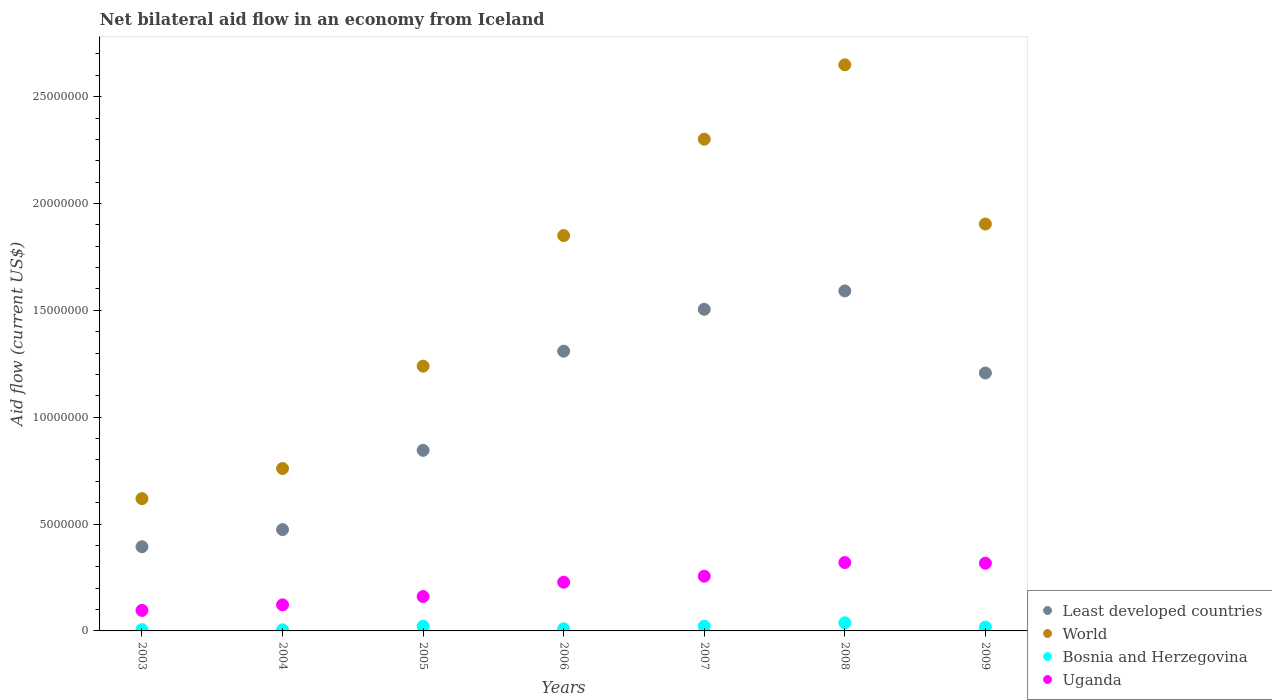How many different coloured dotlines are there?
Make the answer very short. 4. What is the net bilateral aid flow in World in 2008?
Offer a terse response. 2.65e+07. Across all years, what is the maximum net bilateral aid flow in Least developed countries?
Your answer should be very brief. 1.59e+07. Across all years, what is the minimum net bilateral aid flow in World?
Your response must be concise. 6.19e+06. What is the total net bilateral aid flow in World in the graph?
Your answer should be compact. 1.13e+08. What is the difference between the net bilateral aid flow in Uganda in 2008 and that in 2009?
Provide a succinct answer. 3.00e+04. What is the difference between the net bilateral aid flow in Least developed countries in 2006 and the net bilateral aid flow in Uganda in 2005?
Offer a terse response. 1.15e+07. What is the average net bilateral aid flow in Uganda per year?
Provide a short and direct response. 2.14e+06. In the year 2009, what is the difference between the net bilateral aid flow in Bosnia and Herzegovina and net bilateral aid flow in Least developed countries?
Your response must be concise. -1.19e+07. What is the difference between the highest and the second highest net bilateral aid flow in Least developed countries?
Ensure brevity in your answer.  8.60e+05. What is the difference between the highest and the lowest net bilateral aid flow in Least developed countries?
Provide a short and direct response. 1.20e+07. Is the sum of the net bilateral aid flow in Least developed countries in 2004 and 2007 greater than the maximum net bilateral aid flow in Uganda across all years?
Your answer should be very brief. Yes. Is it the case that in every year, the sum of the net bilateral aid flow in Uganda and net bilateral aid flow in Bosnia and Herzegovina  is greater than the sum of net bilateral aid flow in Least developed countries and net bilateral aid flow in World?
Make the answer very short. No. Is it the case that in every year, the sum of the net bilateral aid flow in Least developed countries and net bilateral aid flow in Uganda  is greater than the net bilateral aid flow in Bosnia and Herzegovina?
Make the answer very short. Yes. Does the net bilateral aid flow in Uganda monotonically increase over the years?
Make the answer very short. No. Is the net bilateral aid flow in Bosnia and Herzegovina strictly greater than the net bilateral aid flow in Uganda over the years?
Your answer should be very brief. No. How many dotlines are there?
Provide a short and direct response. 4. What is the difference between two consecutive major ticks on the Y-axis?
Provide a short and direct response. 5.00e+06. Does the graph contain grids?
Ensure brevity in your answer.  No. Where does the legend appear in the graph?
Make the answer very short. Bottom right. How many legend labels are there?
Give a very brief answer. 4. How are the legend labels stacked?
Offer a very short reply. Vertical. What is the title of the graph?
Keep it short and to the point. Net bilateral aid flow in an economy from Iceland. Does "Luxembourg" appear as one of the legend labels in the graph?
Your answer should be compact. No. What is the label or title of the X-axis?
Provide a succinct answer. Years. What is the label or title of the Y-axis?
Your answer should be compact. Aid flow (current US$). What is the Aid flow (current US$) of Least developed countries in 2003?
Offer a terse response. 3.94e+06. What is the Aid flow (current US$) of World in 2003?
Give a very brief answer. 6.19e+06. What is the Aid flow (current US$) of Bosnia and Herzegovina in 2003?
Your answer should be very brief. 6.00e+04. What is the Aid flow (current US$) in Uganda in 2003?
Offer a terse response. 9.60e+05. What is the Aid flow (current US$) of Least developed countries in 2004?
Your answer should be compact. 4.74e+06. What is the Aid flow (current US$) in World in 2004?
Give a very brief answer. 7.60e+06. What is the Aid flow (current US$) of Bosnia and Herzegovina in 2004?
Offer a terse response. 5.00e+04. What is the Aid flow (current US$) of Uganda in 2004?
Your answer should be very brief. 1.22e+06. What is the Aid flow (current US$) of Least developed countries in 2005?
Your answer should be very brief. 8.45e+06. What is the Aid flow (current US$) in World in 2005?
Your answer should be compact. 1.24e+07. What is the Aid flow (current US$) of Bosnia and Herzegovina in 2005?
Keep it short and to the point. 2.20e+05. What is the Aid flow (current US$) of Uganda in 2005?
Your response must be concise. 1.61e+06. What is the Aid flow (current US$) of Least developed countries in 2006?
Provide a short and direct response. 1.31e+07. What is the Aid flow (current US$) of World in 2006?
Offer a terse response. 1.85e+07. What is the Aid flow (current US$) of Uganda in 2006?
Offer a terse response. 2.28e+06. What is the Aid flow (current US$) of Least developed countries in 2007?
Give a very brief answer. 1.50e+07. What is the Aid flow (current US$) of World in 2007?
Make the answer very short. 2.30e+07. What is the Aid flow (current US$) in Bosnia and Herzegovina in 2007?
Your answer should be compact. 2.20e+05. What is the Aid flow (current US$) of Uganda in 2007?
Your response must be concise. 2.56e+06. What is the Aid flow (current US$) of Least developed countries in 2008?
Your answer should be compact. 1.59e+07. What is the Aid flow (current US$) in World in 2008?
Your response must be concise. 2.65e+07. What is the Aid flow (current US$) of Uganda in 2008?
Keep it short and to the point. 3.20e+06. What is the Aid flow (current US$) in Least developed countries in 2009?
Provide a short and direct response. 1.21e+07. What is the Aid flow (current US$) of World in 2009?
Your response must be concise. 1.90e+07. What is the Aid flow (current US$) in Bosnia and Herzegovina in 2009?
Offer a terse response. 1.80e+05. What is the Aid flow (current US$) of Uganda in 2009?
Make the answer very short. 3.17e+06. Across all years, what is the maximum Aid flow (current US$) in Least developed countries?
Your answer should be very brief. 1.59e+07. Across all years, what is the maximum Aid flow (current US$) in World?
Make the answer very short. 2.65e+07. Across all years, what is the maximum Aid flow (current US$) in Uganda?
Offer a very short reply. 3.20e+06. Across all years, what is the minimum Aid flow (current US$) in Least developed countries?
Your answer should be compact. 3.94e+06. Across all years, what is the minimum Aid flow (current US$) in World?
Your answer should be very brief. 6.19e+06. Across all years, what is the minimum Aid flow (current US$) of Uganda?
Offer a very short reply. 9.60e+05. What is the total Aid flow (current US$) of Least developed countries in the graph?
Your response must be concise. 7.32e+07. What is the total Aid flow (current US$) of World in the graph?
Provide a succinct answer. 1.13e+08. What is the total Aid flow (current US$) of Bosnia and Herzegovina in the graph?
Provide a succinct answer. 1.21e+06. What is the total Aid flow (current US$) of Uganda in the graph?
Your answer should be very brief. 1.50e+07. What is the difference between the Aid flow (current US$) of Least developed countries in 2003 and that in 2004?
Offer a very short reply. -8.00e+05. What is the difference between the Aid flow (current US$) of World in 2003 and that in 2004?
Offer a very short reply. -1.41e+06. What is the difference between the Aid flow (current US$) in Bosnia and Herzegovina in 2003 and that in 2004?
Your answer should be very brief. 10000. What is the difference between the Aid flow (current US$) of Uganda in 2003 and that in 2004?
Your answer should be very brief. -2.60e+05. What is the difference between the Aid flow (current US$) in Least developed countries in 2003 and that in 2005?
Provide a succinct answer. -4.51e+06. What is the difference between the Aid flow (current US$) in World in 2003 and that in 2005?
Make the answer very short. -6.20e+06. What is the difference between the Aid flow (current US$) of Uganda in 2003 and that in 2005?
Give a very brief answer. -6.50e+05. What is the difference between the Aid flow (current US$) of Least developed countries in 2003 and that in 2006?
Provide a succinct answer. -9.15e+06. What is the difference between the Aid flow (current US$) of World in 2003 and that in 2006?
Provide a succinct answer. -1.23e+07. What is the difference between the Aid flow (current US$) of Uganda in 2003 and that in 2006?
Give a very brief answer. -1.32e+06. What is the difference between the Aid flow (current US$) in Least developed countries in 2003 and that in 2007?
Provide a succinct answer. -1.11e+07. What is the difference between the Aid flow (current US$) in World in 2003 and that in 2007?
Provide a succinct answer. -1.68e+07. What is the difference between the Aid flow (current US$) in Bosnia and Herzegovina in 2003 and that in 2007?
Your response must be concise. -1.60e+05. What is the difference between the Aid flow (current US$) in Uganda in 2003 and that in 2007?
Your response must be concise. -1.60e+06. What is the difference between the Aid flow (current US$) in Least developed countries in 2003 and that in 2008?
Your answer should be compact. -1.20e+07. What is the difference between the Aid flow (current US$) in World in 2003 and that in 2008?
Keep it short and to the point. -2.03e+07. What is the difference between the Aid flow (current US$) in Bosnia and Herzegovina in 2003 and that in 2008?
Ensure brevity in your answer.  -3.20e+05. What is the difference between the Aid flow (current US$) of Uganda in 2003 and that in 2008?
Provide a short and direct response. -2.24e+06. What is the difference between the Aid flow (current US$) of Least developed countries in 2003 and that in 2009?
Make the answer very short. -8.13e+06. What is the difference between the Aid flow (current US$) in World in 2003 and that in 2009?
Provide a succinct answer. -1.28e+07. What is the difference between the Aid flow (current US$) in Uganda in 2003 and that in 2009?
Your answer should be very brief. -2.21e+06. What is the difference between the Aid flow (current US$) in Least developed countries in 2004 and that in 2005?
Give a very brief answer. -3.71e+06. What is the difference between the Aid flow (current US$) of World in 2004 and that in 2005?
Your response must be concise. -4.79e+06. What is the difference between the Aid flow (current US$) in Uganda in 2004 and that in 2005?
Provide a short and direct response. -3.90e+05. What is the difference between the Aid flow (current US$) of Least developed countries in 2004 and that in 2006?
Keep it short and to the point. -8.35e+06. What is the difference between the Aid flow (current US$) of World in 2004 and that in 2006?
Provide a succinct answer. -1.09e+07. What is the difference between the Aid flow (current US$) of Uganda in 2004 and that in 2006?
Your answer should be compact. -1.06e+06. What is the difference between the Aid flow (current US$) in Least developed countries in 2004 and that in 2007?
Keep it short and to the point. -1.03e+07. What is the difference between the Aid flow (current US$) in World in 2004 and that in 2007?
Ensure brevity in your answer.  -1.54e+07. What is the difference between the Aid flow (current US$) of Uganda in 2004 and that in 2007?
Your answer should be very brief. -1.34e+06. What is the difference between the Aid flow (current US$) in Least developed countries in 2004 and that in 2008?
Ensure brevity in your answer.  -1.12e+07. What is the difference between the Aid flow (current US$) in World in 2004 and that in 2008?
Your answer should be very brief. -1.89e+07. What is the difference between the Aid flow (current US$) in Bosnia and Herzegovina in 2004 and that in 2008?
Your answer should be compact. -3.30e+05. What is the difference between the Aid flow (current US$) of Uganda in 2004 and that in 2008?
Ensure brevity in your answer.  -1.98e+06. What is the difference between the Aid flow (current US$) in Least developed countries in 2004 and that in 2009?
Your response must be concise. -7.33e+06. What is the difference between the Aid flow (current US$) in World in 2004 and that in 2009?
Provide a short and direct response. -1.14e+07. What is the difference between the Aid flow (current US$) of Uganda in 2004 and that in 2009?
Keep it short and to the point. -1.95e+06. What is the difference between the Aid flow (current US$) in Least developed countries in 2005 and that in 2006?
Make the answer very short. -4.64e+06. What is the difference between the Aid flow (current US$) of World in 2005 and that in 2006?
Your answer should be compact. -6.11e+06. What is the difference between the Aid flow (current US$) of Bosnia and Herzegovina in 2005 and that in 2006?
Your response must be concise. 1.20e+05. What is the difference between the Aid flow (current US$) in Uganda in 2005 and that in 2006?
Provide a short and direct response. -6.70e+05. What is the difference between the Aid flow (current US$) of Least developed countries in 2005 and that in 2007?
Make the answer very short. -6.60e+06. What is the difference between the Aid flow (current US$) in World in 2005 and that in 2007?
Offer a very short reply. -1.06e+07. What is the difference between the Aid flow (current US$) in Bosnia and Herzegovina in 2005 and that in 2007?
Provide a short and direct response. 0. What is the difference between the Aid flow (current US$) of Uganda in 2005 and that in 2007?
Offer a terse response. -9.50e+05. What is the difference between the Aid flow (current US$) in Least developed countries in 2005 and that in 2008?
Provide a short and direct response. -7.46e+06. What is the difference between the Aid flow (current US$) of World in 2005 and that in 2008?
Your answer should be compact. -1.41e+07. What is the difference between the Aid flow (current US$) of Uganda in 2005 and that in 2008?
Your response must be concise. -1.59e+06. What is the difference between the Aid flow (current US$) of Least developed countries in 2005 and that in 2009?
Your answer should be very brief. -3.62e+06. What is the difference between the Aid flow (current US$) of World in 2005 and that in 2009?
Provide a succinct answer. -6.65e+06. What is the difference between the Aid flow (current US$) of Bosnia and Herzegovina in 2005 and that in 2009?
Your response must be concise. 4.00e+04. What is the difference between the Aid flow (current US$) in Uganda in 2005 and that in 2009?
Ensure brevity in your answer.  -1.56e+06. What is the difference between the Aid flow (current US$) of Least developed countries in 2006 and that in 2007?
Offer a very short reply. -1.96e+06. What is the difference between the Aid flow (current US$) of World in 2006 and that in 2007?
Your answer should be compact. -4.51e+06. What is the difference between the Aid flow (current US$) of Bosnia and Herzegovina in 2006 and that in 2007?
Your response must be concise. -1.20e+05. What is the difference between the Aid flow (current US$) in Uganda in 2006 and that in 2007?
Provide a short and direct response. -2.80e+05. What is the difference between the Aid flow (current US$) in Least developed countries in 2006 and that in 2008?
Offer a terse response. -2.82e+06. What is the difference between the Aid flow (current US$) of World in 2006 and that in 2008?
Offer a terse response. -7.99e+06. What is the difference between the Aid flow (current US$) of Bosnia and Herzegovina in 2006 and that in 2008?
Your answer should be compact. -2.80e+05. What is the difference between the Aid flow (current US$) of Uganda in 2006 and that in 2008?
Your answer should be compact. -9.20e+05. What is the difference between the Aid flow (current US$) of Least developed countries in 2006 and that in 2009?
Your answer should be compact. 1.02e+06. What is the difference between the Aid flow (current US$) of World in 2006 and that in 2009?
Provide a short and direct response. -5.40e+05. What is the difference between the Aid flow (current US$) in Bosnia and Herzegovina in 2006 and that in 2009?
Your answer should be compact. -8.00e+04. What is the difference between the Aid flow (current US$) of Uganda in 2006 and that in 2009?
Ensure brevity in your answer.  -8.90e+05. What is the difference between the Aid flow (current US$) of Least developed countries in 2007 and that in 2008?
Offer a very short reply. -8.60e+05. What is the difference between the Aid flow (current US$) in World in 2007 and that in 2008?
Offer a terse response. -3.48e+06. What is the difference between the Aid flow (current US$) in Bosnia and Herzegovina in 2007 and that in 2008?
Your answer should be compact. -1.60e+05. What is the difference between the Aid flow (current US$) in Uganda in 2007 and that in 2008?
Your answer should be very brief. -6.40e+05. What is the difference between the Aid flow (current US$) in Least developed countries in 2007 and that in 2009?
Offer a very short reply. 2.98e+06. What is the difference between the Aid flow (current US$) of World in 2007 and that in 2009?
Offer a terse response. 3.97e+06. What is the difference between the Aid flow (current US$) of Bosnia and Herzegovina in 2007 and that in 2009?
Ensure brevity in your answer.  4.00e+04. What is the difference between the Aid flow (current US$) of Uganda in 2007 and that in 2009?
Your response must be concise. -6.10e+05. What is the difference between the Aid flow (current US$) in Least developed countries in 2008 and that in 2009?
Provide a succinct answer. 3.84e+06. What is the difference between the Aid flow (current US$) in World in 2008 and that in 2009?
Ensure brevity in your answer.  7.45e+06. What is the difference between the Aid flow (current US$) in Bosnia and Herzegovina in 2008 and that in 2009?
Provide a short and direct response. 2.00e+05. What is the difference between the Aid flow (current US$) of Uganda in 2008 and that in 2009?
Make the answer very short. 3.00e+04. What is the difference between the Aid flow (current US$) of Least developed countries in 2003 and the Aid flow (current US$) of World in 2004?
Ensure brevity in your answer.  -3.66e+06. What is the difference between the Aid flow (current US$) in Least developed countries in 2003 and the Aid flow (current US$) in Bosnia and Herzegovina in 2004?
Your answer should be compact. 3.89e+06. What is the difference between the Aid flow (current US$) in Least developed countries in 2003 and the Aid flow (current US$) in Uganda in 2004?
Ensure brevity in your answer.  2.72e+06. What is the difference between the Aid flow (current US$) in World in 2003 and the Aid flow (current US$) in Bosnia and Herzegovina in 2004?
Make the answer very short. 6.14e+06. What is the difference between the Aid flow (current US$) in World in 2003 and the Aid flow (current US$) in Uganda in 2004?
Give a very brief answer. 4.97e+06. What is the difference between the Aid flow (current US$) in Bosnia and Herzegovina in 2003 and the Aid flow (current US$) in Uganda in 2004?
Provide a succinct answer. -1.16e+06. What is the difference between the Aid flow (current US$) in Least developed countries in 2003 and the Aid flow (current US$) in World in 2005?
Your response must be concise. -8.45e+06. What is the difference between the Aid flow (current US$) in Least developed countries in 2003 and the Aid flow (current US$) in Bosnia and Herzegovina in 2005?
Provide a short and direct response. 3.72e+06. What is the difference between the Aid flow (current US$) of Least developed countries in 2003 and the Aid flow (current US$) of Uganda in 2005?
Your response must be concise. 2.33e+06. What is the difference between the Aid flow (current US$) of World in 2003 and the Aid flow (current US$) of Bosnia and Herzegovina in 2005?
Your answer should be compact. 5.97e+06. What is the difference between the Aid flow (current US$) in World in 2003 and the Aid flow (current US$) in Uganda in 2005?
Your response must be concise. 4.58e+06. What is the difference between the Aid flow (current US$) in Bosnia and Herzegovina in 2003 and the Aid flow (current US$) in Uganda in 2005?
Offer a terse response. -1.55e+06. What is the difference between the Aid flow (current US$) of Least developed countries in 2003 and the Aid flow (current US$) of World in 2006?
Ensure brevity in your answer.  -1.46e+07. What is the difference between the Aid flow (current US$) of Least developed countries in 2003 and the Aid flow (current US$) of Bosnia and Herzegovina in 2006?
Offer a very short reply. 3.84e+06. What is the difference between the Aid flow (current US$) of Least developed countries in 2003 and the Aid flow (current US$) of Uganda in 2006?
Make the answer very short. 1.66e+06. What is the difference between the Aid flow (current US$) of World in 2003 and the Aid flow (current US$) of Bosnia and Herzegovina in 2006?
Your answer should be very brief. 6.09e+06. What is the difference between the Aid flow (current US$) in World in 2003 and the Aid flow (current US$) in Uganda in 2006?
Your response must be concise. 3.91e+06. What is the difference between the Aid flow (current US$) of Bosnia and Herzegovina in 2003 and the Aid flow (current US$) of Uganda in 2006?
Give a very brief answer. -2.22e+06. What is the difference between the Aid flow (current US$) in Least developed countries in 2003 and the Aid flow (current US$) in World in 2007?
Provide a short and direct response. -1.91e+07. What is the difference between the Aid flow (current US$) in Least developed countries in 2003 and the Aid flow (current US$) in Bosnia and Herzegovina in 2007?
Your answer should be very brief. 3.72e+06. What is the difference between the Aid flow (current US$) in Least developed countries in 2003 and the Aid flow (current US$) in Uganda in 2007?
Provide a short and direct response. 1.38e+06. What is the difference between the Aid flow (current US$) of World in 2003 and the Aid flow (current US$) of Bosnia and Herzegovina in 2007?
Offer a very short reply. 5.97e+06. What is the difference between the Aid flow (current US$) in World in 2003 and the Aid flow (current US$) in Uganda in 2007?
Keep it short and to the point. 3.63e+06. What is the difference between the Aid flow (current US$) of Bosnia and Herzegovina in 2003 and the Aid flow (current US$) of Uganda in 2007?
Your response must be concise. -2.50e+06. What is the difference between the Aid flow (current US$) in Least developed countries in 2003 and the Aid flow (current US$) in World in 2008?
Offer a terse response. -2.26e+07. What is the difference between the Aid flow (current US$) of Least developed countries in 2003 and the Aid flow (current US$) of Bosnia and Herzegovina in 2008?
Keep it short and to the point. 3.56e+06. What is the difference between the Aid flow (current US$) in Least developed countries in 2003 and the Aid flow (current US$) in Uganda in 2008?
Ensure brevity in your answer.  7.40e+05. What is the difference between the Aid flow (current US$) in World in 2003 and the Aid flow (current US$) in Bosnia and Herzegovina in 2008?
Your response must be concise. 5.81e+06. What is the difference between the Aid flow (current US$) in World in 2003 and the Aid flow (current US$) in Uganda in 2008?
Make the answer very short. 2.99e+06. What is the difference between the Aid flow (current US$) of Bosnia and Herzegovina in 2003 and the Aid flow (current US$) of Uganda in 2008?
Keep it short and to the point. -3.14e+06. What is the difference between the Aid flow (current US$) of Least developed countries in 2003 and the Aid flow (current US$) of World in 2009?
Keep it short and to the point. -1.51e+07. What is the difference between the Aid flow (current US$) of Least developed countries in 2003 and the Aid flow (current US$) of Bosnia and Herzegovina in 2009?
Make the answer very short. 3.76e+06. What is the difference between the Aid flow (current US$) of Least developed countries in 2003 and the Aid flow (current US$) of Uganda in 2009?
Your answer should be very brief. 7.70e+05. What is the difference between the Aid flow (current US$) of World in 2003 and the Aid flow (current US$) of Bosnia and Herzegovina in 2009?
Provide a succinct answer. 6.01e+06. What is the difference between the Aid flow (current US$) in World in 2003 and the Aid flow (current US$) in Uganda in 2009?
Provide a short and direct response. 3.02e+06. What is the difference between the Aid flow (current US$) in Bosnia and Herzegovina in 2003 and the Aid flow (current US$) in Uganda in 2009?
Offer a very short reply. -3.11e+06. What is the difference between the Aid flow (current US$) in Least developed countries in 2004 and the Aid flow (current US$) in World in 2005?
Your answer should be compact. -7.65e+06. What is the difference between the Aid flow (current US$) in Least developed countries in 2004 and the Aid flow (current US$) in Bosnia and Herzegovina in 2005?
Your answer should be very brief. 4.52e+06. What is the difference between the Aid flow (current US$) of Least developed countries in 2004 and the Aid flow (current US$) of Uganda in 2005?
Offer a terse response. 3.13e+06. What is the difference between the Aid flow (current US$) of World in 2004 and the Aid flow (current US$) of Bosnia and Herzegovina in 2005?
Ensure brevity in your answer.  7.38e+06. What is the difference between the Aid flow (current US$) of World in 2004 and the Aid flow (current US$) of Uganda in 2005?
Keep it short and to the point. 5.99e+06. What is the difference between the Aid flow (current US$) in Bosnia and Herzegovina in 2004 and the Aid flow (current US$) in Uganda in 2005?
Ensure brevity in your answer.  -1.56e+06. What is the difference between the Aid flow (current US$) of Least developed countries in 2004 and the Aid flow (current US$) of World in 2006?
Provide a short and direct response. -1.38e+07. What is the difference between the Aid flow (current US$) of Least developed countries in 2004 and the Aid flow (current US$) of Bosnia and Herzegovina in 2006?
Your response must be concise. 4.64e+06. What is the difference between the Aid flow (current US$) in Least developed countries in 2004 and the Aid flow (current US$) in Uganda in 2006?
Your response must be concise. 2.46e+06. What is the difference between the Aid flow (current US$) of World in 2004 and the Aid flow (current US$) of Bosnia and Herzegovina in 2006?
Provide a short and direct response. 7.50e+06. What is the difference between the Aid flow (current US$) in World in 2004 and the Aid flow (current US$) in Uganda in 2006?
Give a very brief answer. 5.32e+06. What is the difference between the Aid flow (current US$) of Bosnia and Herzegovina in 2004 and the Aid flow (current US$) of Uganda in 2006?
Offer a terse response. -2.23e+06. What is the difference between the Aid flow (current US$) of Least developed countries in 2004 and the Aid flow (current US$) of World in 2007?
Give a very brief answer. -1.83e+07. What is the difference between the Aid flow (current US$) of Least developed countries in 2004 and the Aid flow (current US$) of Bosnia and Herzegovina in 2007?
Make the answer very short. 4.52e+06. What is the difference between the Aid flow (current US$) in Least developed countries in 2004 and the Aid flow (current US$) in Uganda in 2007?
Provide a short and direct response. 2.18e+06. What is the difference between the Aid flow (current US$) of World in 2004 and the Aid flow (current US$) of Bosnia and Herzegovina in 2007?
Offer a terse response. 7.38e+06. What is the difference between the Aid flow (current US$) in World in 2004 and the Aid flow (current US$) in Uganda in 2007?
Your answer should be compact. 5.04e+06. What is the difference between the Aid flow (current US$) of Bosnia and Herzegovina in 2004 and the Aid flow (current US$) of Uganda in 2007?
Keep it short and to the point. -2.51e+06. What is the difference between the Aid flow (current US$) in Least developed countries in 2004 and the Aid flow (current US$) in World in 2008?
Offer a very short reply. -2.18e+07. What is the difference between the Aid flow (current US$) of Least developed countries in 2004 and the Aid flow (current US$) of Bosnia and Herzegovina in 2008?
Your answer should be very brief. 4.36e+06. What is the difference between the Aid flow (current US$) of Least developed countries in 2004 and the Aid flow (current US$) of Uganda in 2008?
Offer a very short reply. 1.54e+06. What is the difference between the Aid flow (current US$) of World in 2004 and the Aid flow (current US$) of Bosnia and Herzegovina in 2008?
Your response must be concise. 7.22e+06. What is the difference between the Aid flow (current US$) in World in 2004 and the Aid flow (current US$) in Uganda in 2008?
Your response must be concise. 4.40e+06. What is the difference between the Aid flow (current US$) of Bosnia and Herzegovina in 2004 and the Aid flow (current US$) of Uganda in 2008?
Give a very brief answer. -3.15e+06. What is the difference between the Aid flow (current US$) in Least developed countries in 2004 and the Aid flow (current US$) in World in 2009?
Give a very brief answer. -1.43e+07. What is the difference between the Aid flow (current US$) in Least developed countries in 2004 and the Aid flow (current US$) in Bosnia and Herzegovina in 2009?
Offer a very short reply. 4.56e+06. What is the difference between the Aid flow (current US$) in Least developed countries in 2004 and the Aid flow (current US$) in Uganda in 2009?
Make the answer very short. 1.57e+06. What is the difference between the Aid flow (current US$) in World in 2004 and the Aid flow (current US$) in Bosnia and Herzegovina in 2009?
Provide a short and direct response. 7.42e+06. What is the difference between the Aid flow (current US$) of World in 2004 and the Aid flow (current US$) of Uganda in 2009?
Make the answer very short. 4.43e+06. What is the difference between the Aid flow (current US$) in Bosnia and Herzegovina in 2004 and the Aid flow (current US$) in Uganda in 2009?
Provide a short and direct response. -3.12e+06. What is the difference between the Aid flow (current US$) of Least developed countries in 2005 and the Aid flow (current US$) of World in 2006?
Provide a short and direct response. -1.00e+07. What is the difference between the Aid flow (current US$) of Least developed countries in 2005 and the Aid flow (current US$) of Bosnia and Herzegovina in 2006?
Your answer should be compact. 8.35e+06. What is the difference between the Aid flow (current US$) of Least developed countries in 2005 and the Aid flow (current US$) of Uganda in 2006?
Make the answer very short. 6.17e+06. What is the difference between the Aid flow (current US$) of World in 2005 and the Aid flow (current US$) of Bosnia and Herzegovina in 2006?
Provide a short and direct response. 1.23e+07. What is the difference between the Aid flow (current US$) of World in 2005 and the Aid flow (current US$) of Uganda in 2006?
Offer a very short reply. 1.01e+07. What is the difference between the Aid flow (current US$) of Bosnia and Herzegovina in 2005 and the Aid flow (current US$) of Uganda in 2006?
Your response must be concise. -2.06e+06. What is the difference between the Aid flow (current US$) of Least developed countries in 2005 and the Aid flow (current US$) of World in 2007?
Offer a terse response. -1.46e+07. What is the difference between the Aid flow (current US$) in Least developed countries in 2005 and the Aid flow (current US$) in Bosnia and Herzegovina in 2007?
Offer a terse response. 8.23e+06. What is the difference between the Aid flow (current US$) in Least developed countries in 2005 and the Aid flow (current US$) in Uganda in 2007?
Offer a very short reply. 5.89e+06. What is the difference between the Aid flow (current US$) in World in 2005 and the Aid flow (current US$) in Bosnia and Herzegovina in 2007?
Provide a short and direct response. 1.22e+07. What is the difference between the Aid flow (current US$) in World in 2005 and the Aid flow (current US$) in Uganda in 2007?
Your answer should be compact. 9.83e+06. What is the difference between the Aid flow (current US$) of Bosnia and Herzegovina in 2005 and the Aid flow (current US$) of Uganda in 2007?
Provide a succinct answer. -2.34e+06. What is the difference between the Aid flow (current US$) of Least developed countries in 2005 and the Aid flow (current US$) of World in 2008?
Offer a very short reply. -1.80e+07. What is the difference between the Aid flow (current US$) of Least developed countries in 2005 and the Aid flow (current US$) of Bosnia and Herzegovina in 2008?
Your answer should be compact. 8.07e+06. What is the difference between the Aid flow (current US$) in Least developed countries in 2005 and the Aid flow (current US$) in Uganda in 2008?
Give a very brief answer. 5.25e+06. What is the difference between the Aid flow (current US$) in World in 2005 and the Aid flow (current US$) in Bosnia and Herzegovina in 2008?
Your response must be concise. 1.20e+07. What is the difference between the Aid flow (current US$) of World in 2005 and the Aid flow (current US$) of Uganda in 2008?
Offer a terse response. 9.19e+06. What is the difference between the Aid flow (current US$) in Bosnia and Herzegovina in 2005 and the Aid flow (current US$) in Uganda in 2008?
Provide a succinct answer. -2.98e+06. What is the difference between the Aid flow (current US$) in Least developed countries in 2005 and the Aid flow (current US$) in World in 2009?
Your answer should be compact. -1.06e+07. What is the difference between the Aid flow (current US$) of Least developed countries in 2005 and the Aid flow (current US$) of Bosnia and Herzegovina in 2009?
Offer a very short reply. 8.27e+06. What is the difference between the Aid flow (current US$) in Least developed countries in 2005 and the Aid flow (current US$) in Uganda in 2009?
Your response must be concise. 5.28e+06. What is the difference between the Aid flow (current US$) in World in 2005 and the Aid flow (current US$) in Bosnia and Herzegovina in 2009?
Give a very brief answer. 1.22e+07. What is the difference between the Aid flow (current US$) in World in 2005 and the Aid flow (current US$) in Uganda in 2009?
Ensure brevity in your answer.  9.22e+06. What is the difference between the Aid flow (current US$) in Bosnia and Herzegovina in 2005 and the Aid flow (current US$) in Uganda in 2009?
Provide a short and direct response. -2.95e+06. What is the difference between the Aid flow (current US$) of Least developed countries in 2006 and the Aid flow (current US$) of World in 2007?
Offer a very short reply. -9.92e+06. What is the difference between the Aid flow (current US$) of Least developed countries in 2006 and the Aid flow (current US$) of Bosnia and Herzegovina in 2007?
Offer a terse response. 1.29e+07. What is the difference between the Aid flow (current US$) in Least developed countries in 2006 and the Aid flow (current US$) in Uganda in 2007?
Your answer should be compact. 1.05e+07. What is the difference between the Aid flow (current US$) in World in 2006 and the Aid flow (current US$) in Bosnia and Herzegovina in 2007?
Provide a succinct answer. 1.83e+07. What is the difference between the Aid flow (current US$) of World in 2006 and the Aid flow (current US$) of Uganda in 2007?
Ensure brevity in your answer.  1.59e+07. What is the difference between the Aid flow (current US$) in Bosnia and Herzegovina in 2006 and the Aid flow (current US$) in Uganda in 2007?
Keep it short and to the point. -2.46e+06. What is the difference between the Aid flow (current US$) in Least developed countries in 2006 and the Aid flow (current US$) in World in 2008?
Ensure brevity in your answer.  -1.34e+07. What is the difference between the Aid flow (current US$) in Least developed countries in 2006 and the Aid flow (current US$) in Bosnia and Herzegovina in 2008?
Your answer should be very brief. 1.27e+07. What is the difference between the Aid flow (current US$) in Least developed countries in 2006 and the Aid flow (current US$) in Uganda in 2008?
Offer a terse response. 9.89e+06. What is the difference between the Aid flow (current US$) in World in 2006 and the Aid flow (current US$) in Bosnia and Herzegovina in 2008?
Provide a short and direct response. 1.81e+07. What is the difference between the Aid flow (current US$) in World in 2006 and the Aid flow (current US$) in Uganda in 2008?
Your answer should be compact. 1.53e+07. What is the difference between the Aid flow (current US$) in Bosnia and Herzegovina in 2006 and the Aid flow (current US$) in Uganda in 2008?
Your answer should be very brief. -3.10e+06. What is the difference between the Aid flow (current US$) in Least developed countries in 2006 and the Aid flow (current US$) in World in 2009?
Make the answer very short. -5.95e+06. What is the difference between the Aid flow (current US$) of Least developed countries in 2006 and the Aid flow (current US$) of Bosnia and Herzegovina in 2009?
Provide a short and direct response. 1.29e+07. What is the difference between the Aid flow (current US$) of Least developed countries in 2006 and the Aid flow (current US$) of Uganda in 2009?
Provide a succinct answer. 9.92e+06. What is the difference between the Aid flow (current US$) in World in 2006 and the Aid flow (current US$) in Bosnia and Herzegovina in 2009?
Your response must be concise. 1.83e+07. What is the difference between the Aid flow (current US$) of World in 2006 and the Aid flow (current US$) of Uganda in 2009?
Give a very brief answer. 1.53e+07. What is the difference between the Aid flow (current US$) in Bosnia and Herzegovina in 2006 and the Aid flow (current US$) in Uganda in 2009?
Offer a very short reply. -3.07e+06. What is the difference between the Aid flow (current US$) of Least developed countries in 2007 and the Aid flow (current US$) of World in 2008?
Provide a succinct answer. -1.14e+07. What is the difference between the Aid flow (current US$) in Least developed countries in 2007 and the Aid flow (current US$) in Bosnia and Herzegovina in 2008?
Give a very brief answer. 1.47e+07. What is the difference between the Aid flow (current US$) of Least developed countries in 2007 and the Aid flow (current US$) of Uganda in 2008?
Ensure brevity in your answer.  1.18e+07. What is the difference between the Aid flow (current US$) in World in 2007 and the Aid flow (current US$) in Bosnia and Herzegovina in 2008?
Your answer should be very brief. 2.26e+07. What is the difference between the Aid flow (current US$) in World in 2007 and the Aid flow (current US$) in Uganda in 2008?
Offer a very short reply. 1.98e+07. What is the difference between the Aid flow (current US$) in Bosnia and Herzegovina in 2007 and the Aid flow (current US$) in Uganda in 2008?
Keep it short and to the point. -2.98e+06. What is the difference between the Aid flow (current US$) in Least developed countries in 2007 and the Aid flow (current US$) in World in 2009?
Offer a very short reply. -3.99e+06. What is the difference between the Aid flow (current US$) of Least developed countries in 2007 and the Aid flow (current US$) of Bosnia and Herzegovina in 2009?
Provide a succinct answer. 1.49e+07. What is the difference between the Aid flow (current US$) in Least developed countries in 2007 and the Aid flow (current US$) in Uganda in 2009?
Give a very brief answer. 1.19e+07. What is the difference between the Aid flow (current US$) in World in 2007 and the Aid flow (current US$) in Bosnia and Herzegovina in 2009?
Provide a short and direct response. 2.28e+07. What is the difference between the Aid flow (current US$) of World in 2007 and the Aid flow (current US$) of Uganda in 2009?
Offer a terse response. 1.98e+07. What is the difference between the Aid flow (current US$) in Bosnia and Herzegovina in 2007 and the Aid flow (current US$) in Uganda in 2009?
Your answer should be compact. -2.95e+06. What is the difference between the Aid flow (current US$) in Least developed countries in 2008 and the Aid flow (current US$) in World in 2009?
Give a very brief answer. -3.13e+06. What is the difference between the Aid flow (current US$) in Least developed countries in 2008 and the Aid flow (current US$) in Bosnia and Herzegovina in 2009?
Keep it short and to the point. 1.57e+07. What is the difference between the Aid flow (current US$) in Least developed countries in 2008 and the Aid flow (current US$) in Uganda in 2009?
Provide a short and direct response. 1.27e+07. What is the difference between the Aid flow (current US$) of World in 2008 and the Aid flow (current US$) of Bosnia and Herzegovina in 2009?
Your answer should be very brief. 2.63e+07. What is the difference between the Aid flow (current US$) in World in 2008 and the Aid flow (current US$) in Uganda in 2009?
Provide a succinct answer. 2.33e+07. What is the difference between the Aid flow (current US$) in Bosnia and Herzegovina in 2008 and the Aid flow (current US$) in Uganda in 2009?
Your answer should be compact. -2.79e+06. What is the average Aid flow (current US$) of Least developed countries per year?
Ensure brevity in your answer.  1.05e+07. What is the average Aid flow (current US$) of World per year?
Offer a terse response. 1.62e+07. What is the average Aid flow (current US$) in Bosnia and Herzegovina per year?
Keep it short and to the point. 1.73e+05. What is the average Aid flow (current US$) in Uganda per year?
Offer a very short reply. 2.14e+06. In the year 2003, what is the difference between the Aid flow (current US$) of Least developed countries and Aid flow (current US$) of World?
Keep it short and to the point. -2.25e+06. In the year 2003, what is the difference between the Aid flow (current US$) in Least developed countries and Aid flow (current US$) in Bosnia and Herzegovina?
Your response must be concise. 3.88e+06. In the year 2003, what is the difference between the Aid flow (current US$) in Least developed countries and Aid flow (current US$) in Uganda?
Offer a terse response. 2.98e+06. In the year 2003, what is the difference between the Aid flow (current US$) of World and Aid flow (current US$) of Bosnia and Herzegovina?
Offer a very short reply. 6.13e+06. In the year 2003, what is the difference between the Aid flow (current US$) of World and Aid flow (current US$) of Uganda?
Your response must be concise. 5.23e+06. In the year 2003, what is the difference between the Aid flow (current US$) in Bosnia and Herzegovina and Aid flow (current US$) in Uganda?
Your response must be concise. -9.00e+05. In the year 2004, what is the difference between the Aid flow (current US$) in Least developed countries and Aid flow (current US$) in World?
Make the answer very short. -2.86e+06. In the year 2004, what is the difference between the Aid flow (current US$) in Least developed countries and Aid flow (current US$) in Bosnia and Herzegovina?
Ensure brevity in your answer.  4.69e+06. In the year 2004, what is the difference between the Aid flow (current US$) of Least developed countries and Aid flow (current US$) of Uganda?
Offer a very short reply. 3.52e+06. In the year 2004, what is the difference between the Aid flow (current US$) in World and Aid flow (current US$) in Bosnia and Herzegovina?
Keep it short and to the point. 7.55e+06. In the year 2004, what is the difference between the Aid flow (current US$) of World and Aid flow (current US$) of Uganda?
Provide a short and direct response. 6.38e+06. In the year 2004, what is the difference between the Aid flow (current US$) in Bosnia and Herzegovina and Aid flow (current US$) in Uganda?
Your answer should be very brief. -1.17e+06. In the year 2005, what is the difference between the Aid flow (current US$) in Least developed countries and Aid flow (current US$) in World?
Keep it short and to the point. -3.94e+06. In the year 2005, what is the difference between the Aid flow (current US$) of Least developed countries and Aid flow (current US$) of Bosnia and Herzegovina?
Ensure brevity in your answer.  8.23e+06. In the year 2005, what is the difference between the Aid flow (current US$) in Least developed countries and Aid flow (current US$) in Uganda?
Make the answer very short. 6.84e+06. In the year 2005, what is the difference between the Aid flow (current US$) in World and Aid flow (current US$) in Bosnia and Herzegovina?
Ensure brevity in your answer.  1.22e+07. In the year 2005, what is the difference between the Aid flow (current US$) in World and Aid flow (current US$) in Uganda?
Your response must be concise. 1.08e+07. In the year 2005, what is the difference between the Aid flow (current US$) of Bosnia and Herzegovina and Aid flow (current US$) of Uganda?
Your answer should be very brief. -1.39e+06. In the year 2006, what is the difference between the Aid flow (current US$) of Least developed countries and Aid flow (current US$) of World?
Offer a terse response. -5.41e+06. In the year 2006, what is the difference between the Aid flow (current US$) of Least developed countries and Aid flow (current US$) of Bosnia and Herzegovina?
Make the answer very short. 1.30e+07. In the year 2006, what is the difference between the Aid flow (current US$) of Least developed countries and Aid flow (current US$) of Uganda?
Ensure brevity in your answer.  1.08e+07. In the year 2006, what is the difference between the Aid flow (current US$) of World and Aid flow (current US$) of Bosnia and Herzegovina?
Your answer should be compact. 1.84e+07. In the year 2006, what is the difference between the Aid flow (current US$) in World and Aid flow (current US$) in Uganda?
Your answer should be compact. 1.62e+07. In the year 2006, what is the difference between the Aid flow (current US$) in Bosnia and Herzegovina and Aid flow (current US$) in Uganda?
Offer a terse response. -2.18e+06. In the year 2007, what is the difference between the Aid flow (current US$) in Least developed countries and Aid flow (current US$) in World?
Provide a short and direct response. -7.96e+06. In the year 2007, what is the difference between the Aid flow (current US$) of Least developed countries and Aid flow (current US$) of Bosnia and Herzegovina?
Make the answer very short. 1.48e+07. In the year 2007, what is the difference between the Aid flow (current US$) in Least developed countries and Aid flow (current US$) in Uganda?
Offer a very short reply. 1.25e+07. In the year 2007, what is the difference between the Aid flow (current US$) of World and Aid flow (current US$) of Bosnia and Herzegovina?
Provide a succinct answer. 2.28e+07. In the year 2007, what is the difference between the Aid flow (current US$) in World and Aid flow (current US$) in Uganda?
Offer a terse response. 2.04e+07. In the year 2007, what is the difference between the Aid flow (current US$) in Bosnia and Herzegovina and Aid flow (current US$) in Uganda?
Your answer should be compact. -2.34e+06. In the year 2008, what is the difference between the Aid flow (current US$) in Least developed countries and Aid flow (current US$) in World?
Your answer should be very brief. -1.06e+07. In the year 2008, what is the difference between the Aid flow (current US$) in Least developed countries and Aid flow (current US$) in Bosnia and Herzegovina?
Offer a terse response. 1.55e+07. In the year 2008, what is the difference between the Aid flow (current US$) of Least developed countries and Aid flow (current US$) of Uganda?
Your answer should be compact. 1.27e+07. In the year 2008, what is the difference between the Aid flow (current US$) of World and Aid flow (current US$) of Bosnia and Herzegovina?
Your response must be concise. 2.61e+07. In the year 2008, what is the difference between the Aid flow (current US$) of World and Aid flow (current US$) of Uganda?
Offer a very short reply. 2.33e+07. In the year 2008, what is the difference between the Aid flow (current US$) in Bosnia and Herzegovina and Aid flow (current US$) in Uganda?
Make the answer very short. -2.82e+06. In the year 2009, what is the difference between the Aid flow (current US$) of Least developed countries and Aid flow (current US$) of World?
Keep it short and to the point. -6.97e+06. In the year 2009, what is the difference between the Aid flow (current US$) of Least developed countries and Aid flow (current US$) of Bosnia and Herzegovina?
Give a very brief answer. 1.19e+07. In the year 2009, what is the difference between the Aid flow (current US$) in Least developed countries and Aid flow (current US$) in Uganda?
Provide a succinct answer. 8.90e+06. In the year 2009, what is the difference between the Aid flow (current US$) in World and Aid flow (current US$) in Bosnia and Herzegovina?
Provide a short and direct response. 1.89e+07. In the year 2009, what is the difference between the Aid flow (current US$) in World and Aid flow (current US$) in Uganda?
Your response must be concise. 1.59e+07. In the year 2009, what is the difference between the Aid flow (current US$) in Bosnia and Herzegovina and Aid flow (current US$) in Uganda?
Offer a terse response. -2.99e+06. What is the ratio of the Aid flow (current US$) in Least developed countries in 2003 to that in 2004?
Provide a succinct answer. 0.83. What is the ratio of the Aid flow (current US$) of World in 2003 to that in 2004?
Your answer should be very brief. 0.81. What is the ratio of the Aid flow (current US$) of Bosnia and Herzegovina in 2003 to that in 2004?
Offer a very short reply. 1.2. What is the ratio of the Aid flow (current US$) of Uganda in 2003 to that in 2004?
Offer a terse response. 0.79. What is the ratio of the Aid flow (current US$) in Least developed countries in 2003 to that in 2005?
Give a very brief answer. 0.47. What is the ratio of the Aid flow (current US$) in World in 2003 to that in 2005?
Offer a very short reply. 0.5. What is the ratio of the Aid flow (current US$) of Bosnia and Herzegovina in 2003 to that in 2005?
Offer a terse response. 0.27. What is the ratio of the Aid flow (current US$) in Uganda in 2003 to that in 2005?
Offer a terse response. 0.6. What is the ratio of the Aid flow (current US$) of Least developed countries in 2003 to that in 2006?
Your answer should be very brief. 0.3. What is the ratio of the Aid flow (current US$) of World in 2003 to that in 2006?
Ensure brevity in your answer.  0.33. What is the ratio of the Aid flow (current US$) in Uganda in 2003 to that in 2006?
Your answer should be compact. 0.42. What is the ratio of the Aid flow (current US$) of Least developed countries in 2003 to that in 2007?
Provide a short and direct response. 0.26. What is the ratio of the Aid flow (current US$) of World in 2003 to that in 2007?
Make the answer very short. 0.27. What is the ratio of the Aid flow (current US$) of Bosnia and Herzegovina in 2003 to that in 2007?
Offer a very short reply. 0.27. What is the ratio of the Aid flow (current US$) in Least developed countries in 2003 to that in 2008?
Ensure brevity in your answer.  0.25. What is the ratio of the Aid flow (current US$) in World in 2003 to that in 2008?
Keep it short and to the point. 0.23. What is the ratio of the Aid flow (current US$) in Bosnia and Herzegovina in 2003 to that in 2008?
Offer a terse response. 0.16. What is the ratio of the Aid flow (current US$) in Uganda in 2003 to that in 2008?
Provide a short and direct response. 0.3. What is the ratio of the Aid flow (current US$) in Least developed countries in 2003 to that in 2009?
Offer a terse response. 0.33. What is the ratio of the Aid flow (current US$) of World in 2003 to that in 2009?
Make the answer very short. 0.33. What is the ratio of the Aid flow (current US$) in Bosnia and Herzegovina in 2003 to that in 2009?
Provide a succinct answer. 0.33. What is the ratio of the Aid flow (current US$) in Uganda in 2003 to that in 2009?
Your response must be concise. 0.3. What is the ratio of the Aid flow (current US$) of Least developed countries in 2004 to that in 2005?
Provide a short and direct response. 0.56. What is the ratio of the Aid flow (current US$) in World in 2004 to that in 2005?
Your answer should be very brief. 0.61. What is the ratio of the Aid flow (current US$) in Bosnia and Herzegovina in 2004 to that in 2005?
Provide a short and direct response. 0.23. What is the ratio of the Aid flow (current US$) of Uganda in 2004 to that in 2005?
Provide a short and direct response. 0.76. What is the ratio of the Aid flow (current US$) of Least developed countries in 2004 to that in 2006?
Give a very brief answer. 0.36. What is the ratio of the Aid flow (current US$) of World in 2004 to that in 2006?
Give a very brief answer. 0.41. What is the ratio of the Aid flow (current US$) of Uganda in 2004 to that in 2006?
Give a very brief answer. 0.54. What is the ratio of the Aid flow (current US$) in Least developed countries in 2004 to that in 2007?
Offer a terse response. 0.32. What is the ratio of the Aid flow (current US$) of World in 2004 to that in 2007?
Your answer should be very brief. 0.33. What is the ratio of the Aid flow (current US$) of Bosnia and Herzegovina in 2004 to that in 2007?
Your answer should be compact. 0.23. What is the ratio of the Aid flow (current US$) of Uganda in 2004 to that in 2007?
Offer a very short reply. 0.48. What is the ratio of the Aid flow (current US$) of Least developed countries in 2004 to that in 2008?
Provide a short and direct response. 0.3. What is the ratio of the Aid flow (current US$) of World in 2004 to that in 2008?
Provide a short and direct response. 0.29. What is the ratio of the Aid flow (current US$) in Bosnia and Herzegovina in 2004 to that in 2008?
Give a very brief answer. 0.13. What is the ratio of the Aid flow (current US$) in Uganda in 2004 to that in 2008?
Offer a very short reply. 0.38. What is the ratio of the Aid flow (current US$) of Least developed countries in 2004 to that in 2009?
Your answer should be compact. 0.39. What is the ratio of the Aid flow (current US$) of World in 2004 to that in 2009?
Make the answer very short. 0.4. What is the ratio of the Aid flow (current US$) of Bosnia and Herzegovina in 2004 to that in 2009?
Make the answer very short. 0.28. What is the ratio of the Aid flow (current US$) in Uganda in 2004 to that in 2009?
Your answer should be very brief. 0.38. What is the ratio of the Aid flow (current US$) of Least developed countries in 2005 to that in 2006?
Your answer should be compact. 0.65. What is the ratio of the Aid flow (current US$) of World in 2005 to that in 2006?
Your response must be concise. 0.67. What is the ratio of the Aid flow (current US$) in Bosnia and Herzegovina in 2005 to that in 2006?
Provide a short and direct response. 2.2. What is the ratio of the Aid flow (current US$) of Uganda in 2005 to that in 2006?
Give a very brief answer. 0.71. What is the ratio of the Aid flow (current US$) of Least developed countries in 2005 to that in 2007?
Offer a terse response. 0.56. What is the ratio of the Aid flow (current US$) in World in 2005 to that in 2007?
Provide a short and direct response. 0.54. What is the ratio of the Aid flow (current US$) of Bosnia and Herzegovina in 2005 to that in 2007?
Offer a terse response. 1. What is the ratio of the Aid flow (current US$) in Uganda in 2005 to that in 2007?
Your answer should be very brief. 0.63. What is the ratio of the Aid flow (current US$) in Least developed countries in 2005 to that in 2008?
Keep it short and to the point. 0.53. What is the ratio of the Aid flow (current US$) in World in 2005 to that in 2008?
Make the answer very short. 0.47. What is the ratio of the Aid flow (current US$) in Bosnia and Herzegovina in 2005 to that in 2008?
Your response must be concise. 0.58. What is the ratio of the Aid flow (current US$) of Uganda in 2005 to that in 2008?
Keep it short and to the point. 0.5. What is the ratio of the Aid flow (current US$) of Least developed countries in 2005 to that in 2009?
Provide a succinct answer. 0.7. What is the ratio of the Aid flow (current US$) in World in 2005 to that in 2009?
Provide a succinct answer. 0.65. What is the ratio of the Aid flow (current US$) in Bosnia and Herzegovina in 2005 to that in 2009?
Keep it short and to the point. 1.22. What is the ratio of the Aid flow (current US$) in Uganda in 2005 to that in 2009?
Ensure brevity in your answer.  0.51. What is the ratio of the Aid flow (current US$) of Least developed countries in 2006 to that in 2007?
Give a very brief answer. 0.87. What is the ratio of the Aid flow (current US$) in World in 2006 to that in 2007?
Give a very brief answer. 0.8. What is the ratio of the Aid flow (current US$) in Bosnia and Herzegovina in 2006 to that in 2007?
Your answer should be compact. 0.45. What is the ratio of the Aid flow (current US$) of Uganda in 2006 to that in 2007?
Provide a succinct answer. 0.89. What is the ratio of the Aid flow (current US$) of Least developed countries in 2006 to that in 2008?
Provide a short and direct response. 0.82. What is the ratio of the Aid flow (current US$) in World in 2006 to that in 2008?
Offer a terse response. 0.7. What is the ratio of the Aid flow (current US$) of Bosnia and Herzegovina in 2006 to that in 2008?
Your answer should be compact. 0.26. What is the ratio of the Aid flow (current US$) of Uganda in 2006 to that in 2008?
Offer a terse response. 0.71. What is the ratio of the Aid flow (current US$) in Least developed countries in 2006 to that in 2009?
Provide a succinct answer. 1.08. What is the ratio of the Aid flow (current US$) in World in 2006 to that in 2009?
Your answer should be very brief. 0.97. What is the ratio of the Aid flow (current US$) of Bosnia and Herzegovina in 2006 to that in 2009?
Give a very brief answer. 0.56. What is the ratio of the Aid flow (current US$) of Uganda in 2006 to that in 2009?
Ensure brevity in your answer.  0.72. What is the ratio of the Aid flow (current US$) in Least developed countries in 2007 to that in 2008?
Make the answer very short. 0.95. What is the ratio of the Aid flow (current US$) in World in 2007 to that in 2008?
Give a very brief answer. 0.87. What is the ratio of the Aid flow (current US$) of Bosnia and Herzegovina in 2007 to that in 2008?
Offer a terse response. 0.58. What is the ratio of the Aid flow (current US$) of Uganda in 2007 to that in 2008?
Provide a short and direct response. 0.8. What is the ratio of the Aid flow (current US$) in Least developed countries in 2007 to that in 2009?
Offer a terse response. 1.25. What is the ratio of the Aid flow (current US$) of World in 2007 to that in 2009?
Offer a very short reply. 1.21. What is the ratio of the Aid flow (current US$) in Bosnia and Herzegovina in 2007 to that in 2009?
Your answer should be compact. 1.22. What is the ratio of the Aid flow (current US$) of Uganda in 2007 to that in 2009?
Your answer should be very brief. 0.81. What is the ratio of the Aid flow (current US$) in Least developed countries in 2008 to that in 2009?
Your answer should be very brief. 1.32. What is the ratio of the Aid flow (current US$) of World in 2008 to that in 2009?
Offer a very short reply. 1.39. What is the ratio of the Aid flow (current US$) of Bosnia and Herzegovina in 2008 to that in 2009?
Offer a very short reply. 2.11. What is the ratio of the Aid flow (current US$) in Uganda in 2008 to that in 2009?
Provide a succinct answer. 1.01. What is the difference between the highest and the second highest Aid flow (current US$) in Least developed countries?
Your answer should be very brief. 8.60e+05. What is the difference between the highest and the second highest Aid flow (current US$) in World?
Your answer should be very brief. 3.48e+06. What is the difference between the highest and the second highest Aid flow (current US$) of Uganda?
Your answer should be very brief. 3.00e+04. What is the difference between the highest and the lowest Aid flow (current US$) of Least developed countries?
Ensure brevity in your answer.  1.20e+07. What is the difference between the highest and the lowest Aid flow (current US$) of World?
Offer a very short reply. 2.03e+07. What is the difference between the highest and the lowest Aid flow (current US$) in Uganda?
Keep it short and to the point. 2.24e+06. 